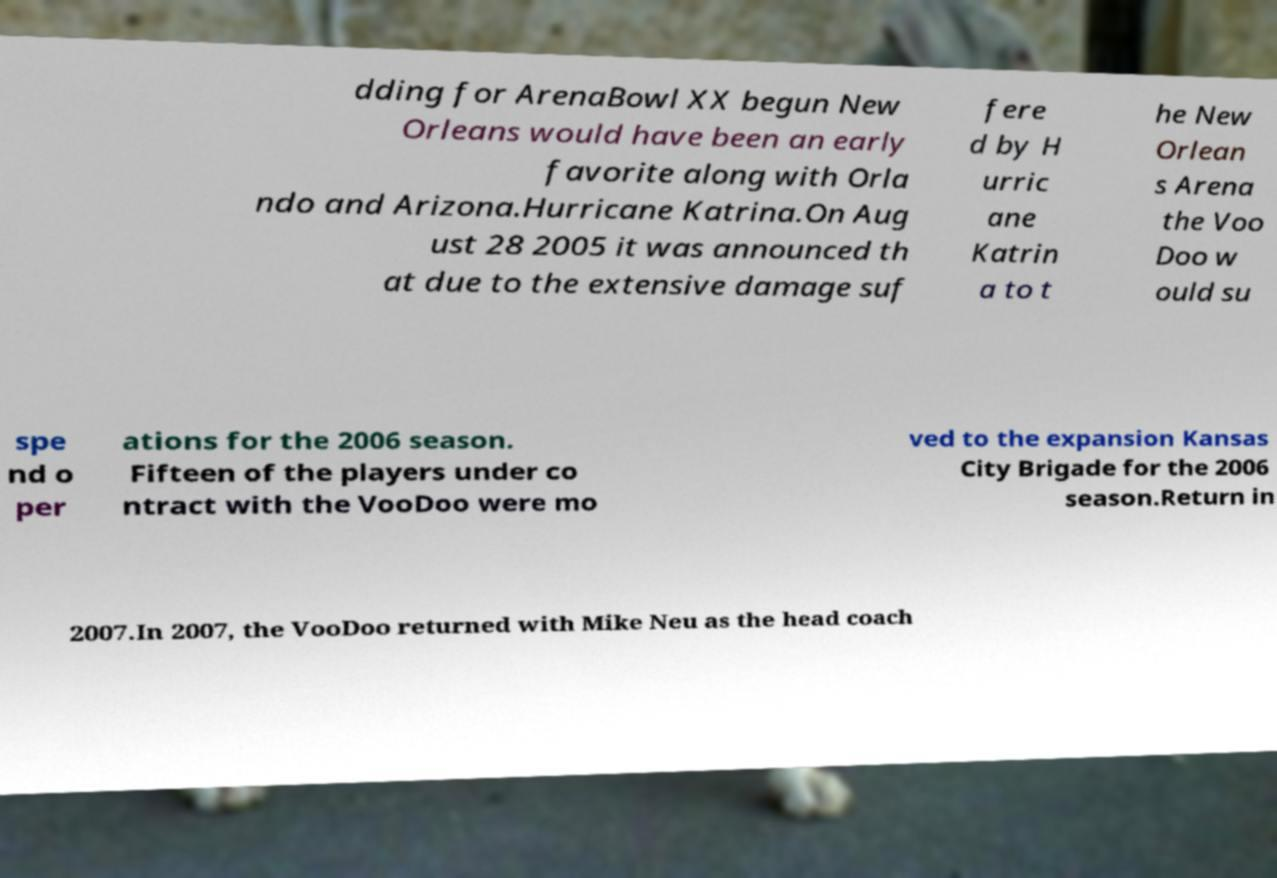Can you accurately transcribe the text from the provided image for me? dding for ArenaBowl XX begun New Orleans would have been an early favorite along with Orla ndo and Arizona.Hurricane Katrina.On Aug ust 28 2005 it was announced th at due to the extensive damage suf fere d by H urric ane Katrin a to t he New Orlean s Arena the Voo Doo w ould su spe nd o per ations for the 2006 season. Fifteen of the players under co ntract with the VooDoo were mo ved to the expansion Kansas City Brigade for the 2006 season.Return in 2007.In 2007, the VooDoo returned with Mike Neu as the head coach 